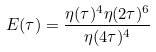Convert formula to latex. <formula><loc_0><loc_0><loc_500><loc_500>E ( \tau ) = \frac { \eta ( \tau ) ^ { 4 } \eta ( 2 \tau ) ^ { 6 } } { \eta ( 4 \tau ) ^ { 4 } }</formula> 